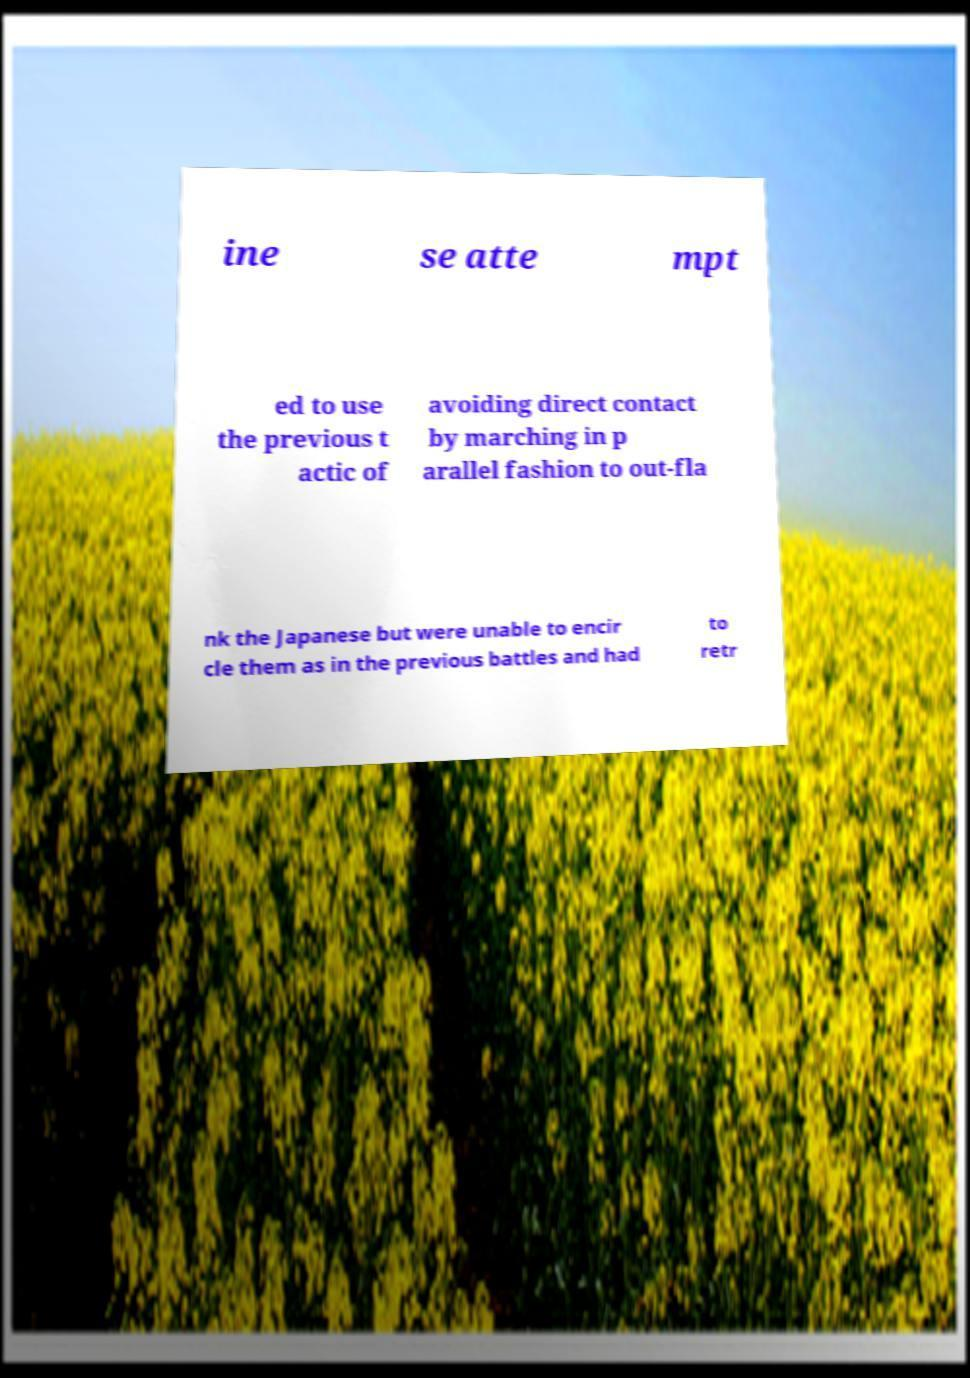Please identify and transcribe the text found in this image. ine se atte mpt ed to use the previous t actic of avoiding direct contact by marching in p arallel fashion to out-fla nk the Japanese but were unable to encir cle them as in the previous battles and had to retr 